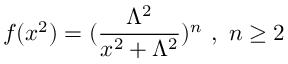Convert formula to latex. <formula><loc_0><loc_0><loc_500><loc_500>f ( x ^ { 2 } ) = ( \frac { \Lambda ^ { 2 } } { x ^ { 2 } + \Lambda ^ { 2 } } ) ^ { n } \ , \ n \geq 2</formula> 